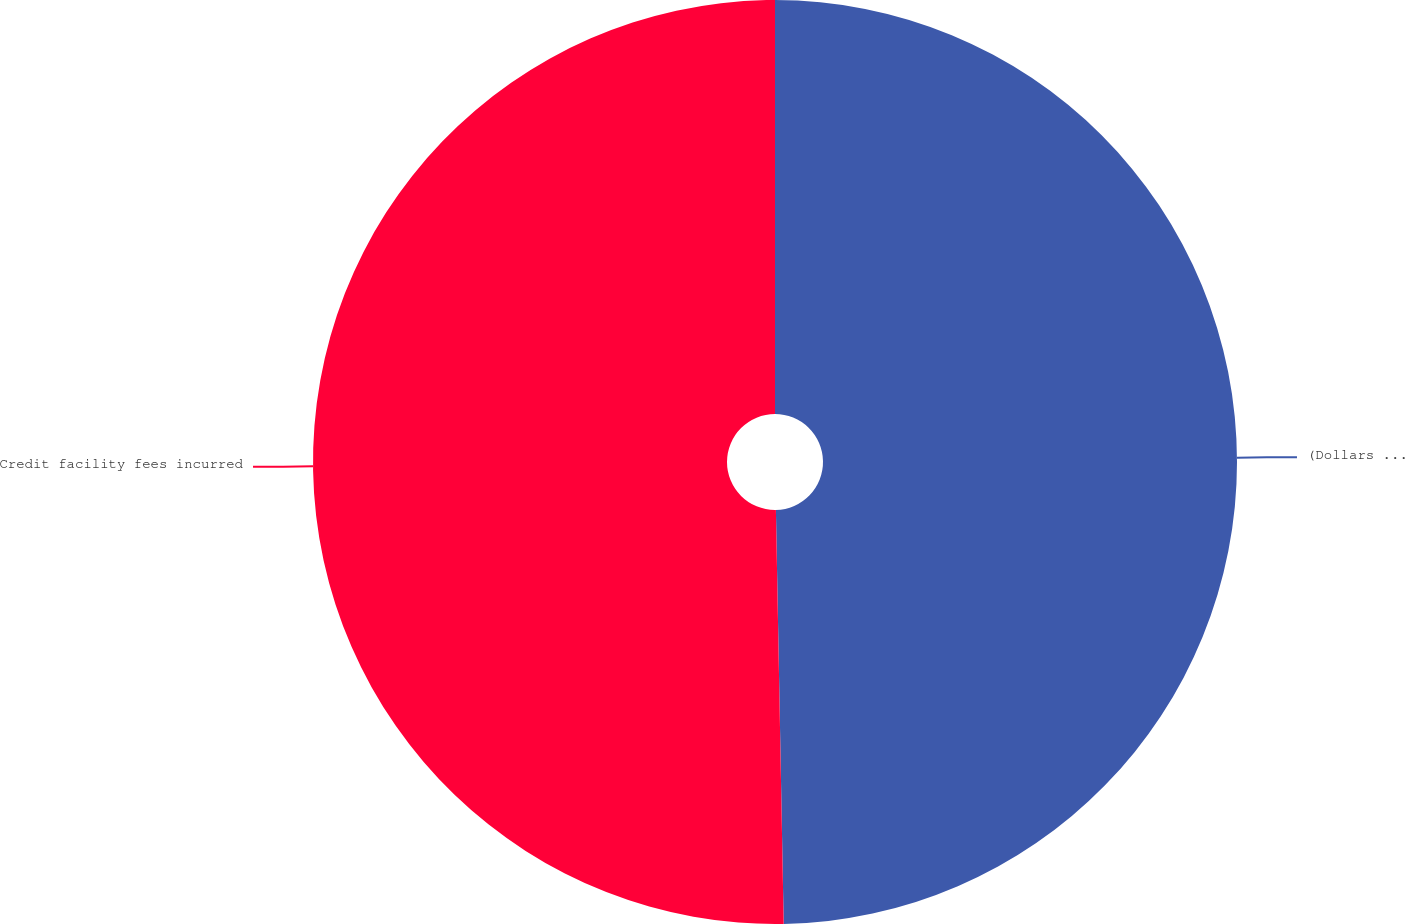<chart> <loc_0><loc_0><loc_500><loc_500><pie_chart><fcel>(Dollars in thousands)<fcel>Credit facility fees incurred<nl><fcel>49.7%<fcel>50.3%<nl></chart> 